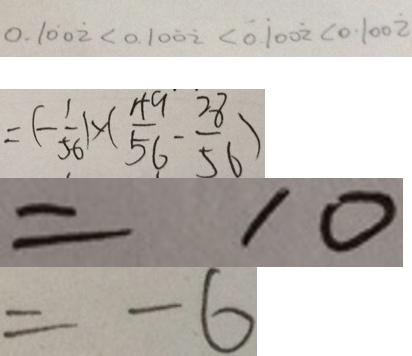Convert formula to latex. <formula><loc_0><loc_0><loc_500><loc_500>0 . 1 \dot { 0 } 0 \dot { 2 } < 0 . 1 0 \dot { 0 } \dot { 2 } < 0 . \dot { 1 } 0 0 \dot { 2 } < 0 . 1 0 0 \dot { 2 } 
 = ( - \frac { 1 } { 5 6 } ) \times ( \frac { 4 9 } { 5 6 } - \frac { 2 8 } { 5 6 } ) 
 = 1 0 
 = - 6</formula> 